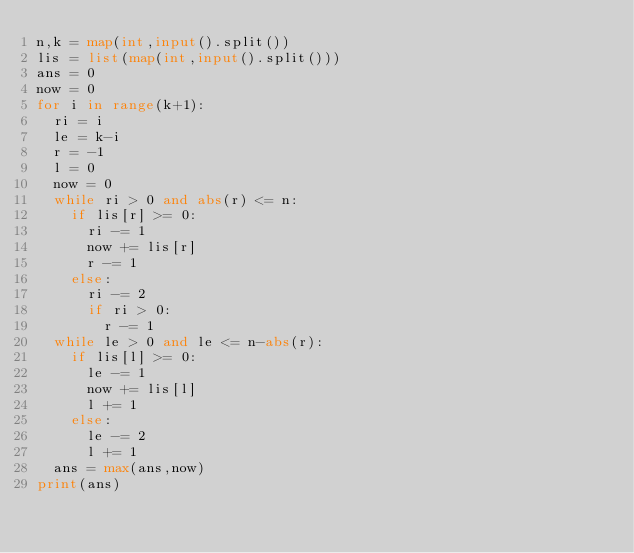<code> <loc_0><loc_0><loc_500><loc_500><_Python_>n,k = map(int,input().split())
lis = list(map(int,input().split()))
ans = 0
now = 0
for i in range(k+1):
  ri = i
  le = k-i
  r = -1
  l = 0
  now = 0
  while ri > 0 and abs(r) <= n:
    if lis[r] >= 0:
      ri -= 1
      now += lis[r]
      r -= 1
    else:
      ri -= 2
      if ri > 0:
        r -= 1
  while le > 0 and le <= n-abs(r):
    if lis[l] >= 0:
      le -= 1
      now += lis[l]
      l += 1
    else:
      le -= 2
      l += 1
  ans = max(ans,now)
print(ans)</code> 